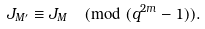<formula> <loc_0><loc_0><loc_500><loc_500>J _ { M ^ { \prime } } \equiv J _ { M } \pmod { ( q ^ { 2 m } - 1 ) } .</formula> 